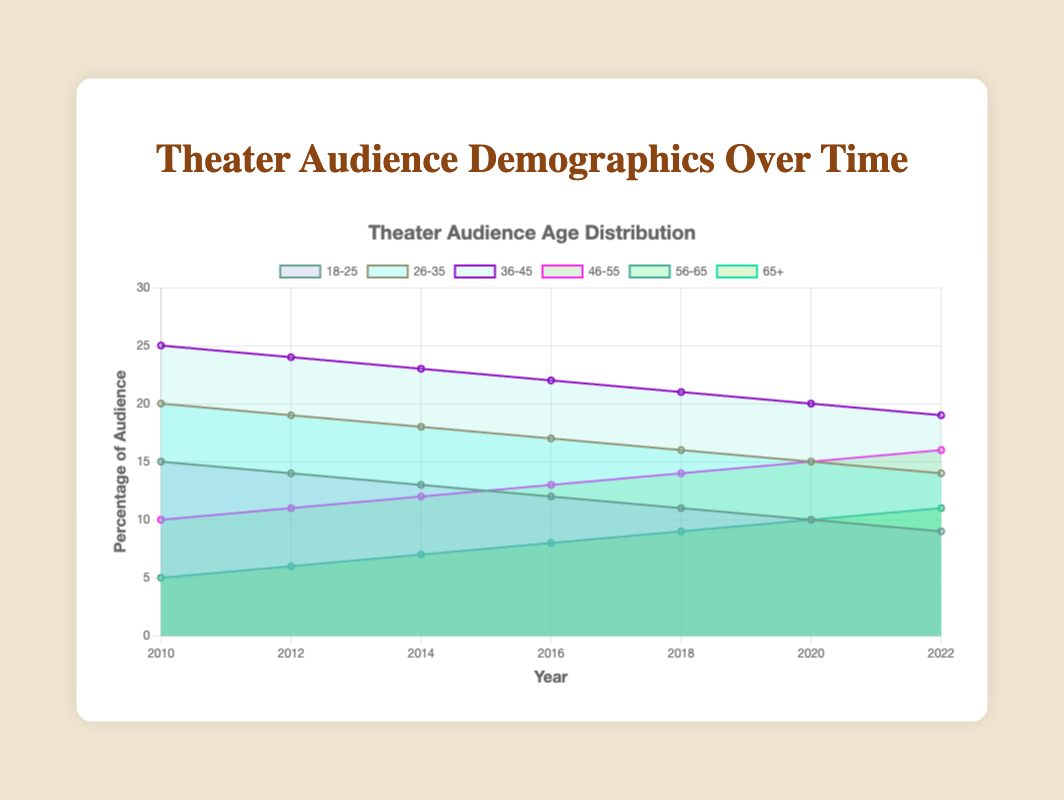What is the title of the chart? The title is displayed at the top of the chart. By looking at the figure, you can see the text "Theater Audience Demographics Over Time".
Answer: Theater Audience Demographics Over Time Which age group has the highest percentage of the audience in 2010? The age group with the highest percentage can be seen by checking the data points for the year 2010 across all age groups. The 36-45 age group has the highest percentage at 25%.
Answer: 36-45 How has the percentage of the 18-25 age group changed from 2010 to 2022? To find the change, look at the values for the 18-25 age group in 2010 (15%) and 2022 (9%). The change is calculated by subtracting the 2022 value from the 2010 value: 15% - 9% = 6%.
Answer: Decreased by 6% Which age group showed an increase in audience percentage over the years 2010 to 2022? Compare the initial and final percentages for each age group. The 46-55, 56-65, and 65+ age groups show an increase. For example, the 46-55 age group increases from 10% in 2010 to 16% in 2022.
Answer: 46-55, 56-65, 65+ In which year did the 26-35 age group and 36-45 age group have the same percentage of the audience? Compare the data points for both the 26-35 and 36-45 age groups across all the years. In 2022, both age groups have a percentage of 14% and 19%, respectively, indicating equal percentages do not occur in the data span.
Answer: Never equal What is the difference in audience percentage between the 46-55 age group and the 65+ age group in 2022? Look at the values for both age groups in 2022. The 46-55 group has 16% and the 65+ group has 11%. The difference is calculated as 16% - 11% = 5%.
Answer: 5% How many age groups experienced a decline in audience percentage from 2010 to 2022? Check the percentages for each age group in 2010 and 2022. The 18-25, 26-35, and 36-45 age groups all show a decline.
Answer: 3 Which age group had the most stable audience percentage across the years? Identify the age group with the smallest changes in percentage values over the years. The 65+ age group changes steadily from 5% in 2010 to 11% in 2022 without any significant fluctuations.
Answer: 65+ What is the combined percentage of the audience for age groups 56-65 and 65+ in 2022? Add the percentages for the 56-65 and 65+ groups in 2022: 11% + 11% = 22%.
Answer: 22% Which age group has the steepest decline in audience percentage from 2010 to 2022? Compare the decrease in percentages for each age group from 2010 to 2022. The 18-25 age group declines from 15% to 9%, which is a 6% drop.
Answer: 18-25 